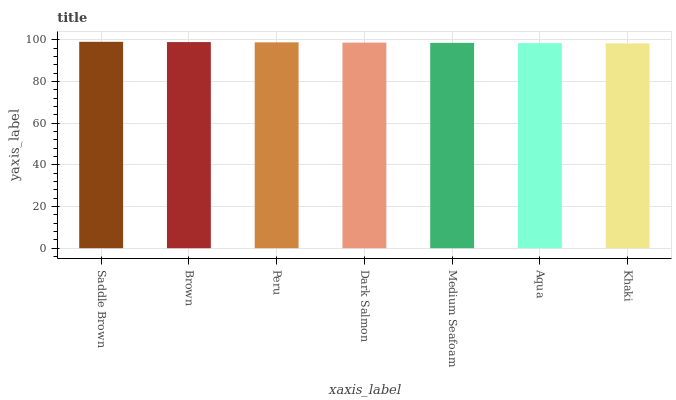Is Khaki the minimum?
Answer yes or no. Yes. Is Saddle Brown the maximum?
Answer yes or no. Yes. Is Brown the minimum?
Answer yes or no. No. Is Brown the maximum?
Answer yes or no. No. Is Saddle Brown greater than Brown?
Answer yes or no. Yes. Is Brown less than Saddle Brown?
Answer yes or no. Yes. Is Brown greater than Saddle Brown?
Answer yes or no. No. Is Saddle Brown less than Brown?
Answer yes or no. No. Is Dark Salmon the high median?
Answer yes or no. Yes. Is Dark Salmon the low median?
Answer yes or no. Yes. Is Brown the high median?
Answer yes or no. No. Is Khaki the low median?
Answer yes or no. No. 